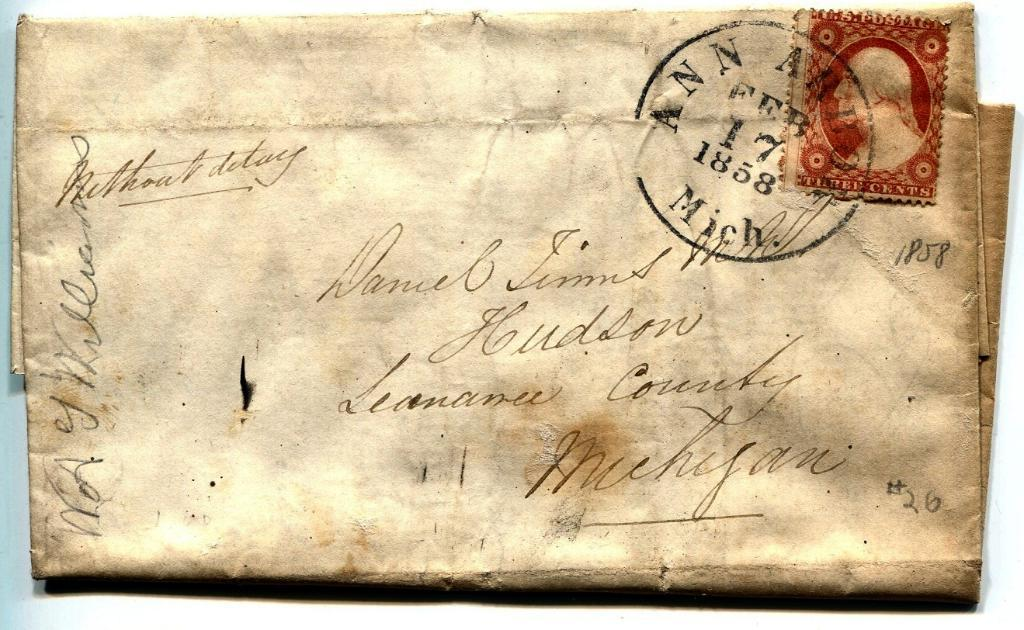<image>
Give a short and clear explanation of the subsequent image. a postal note with the number 17 on it 